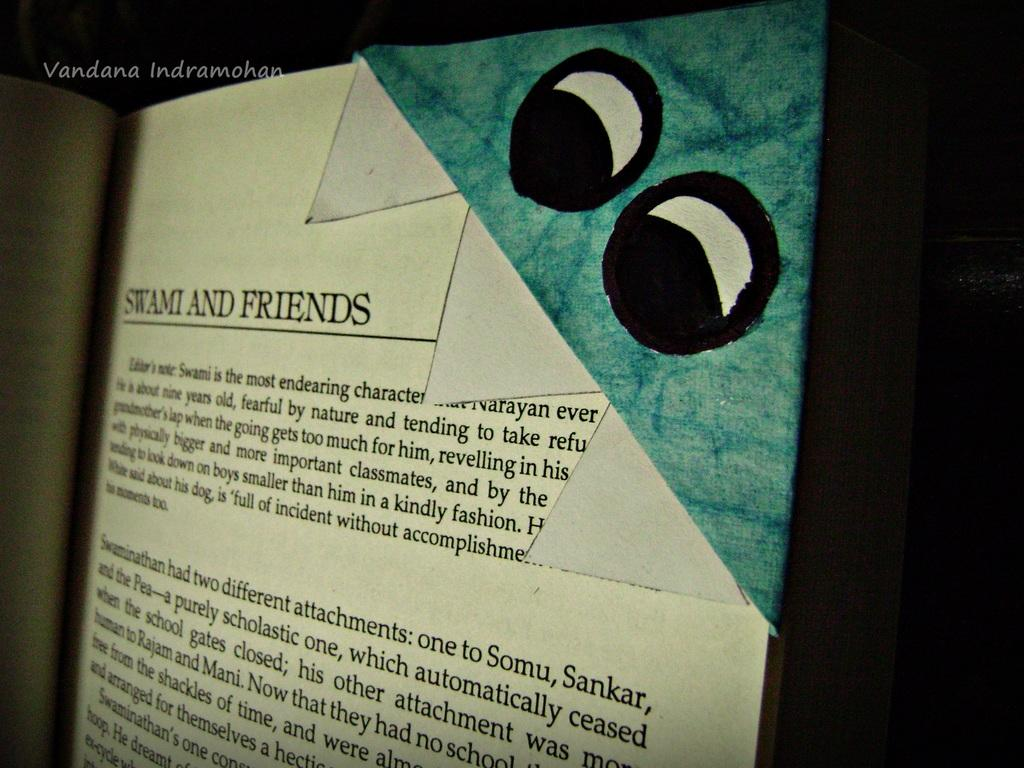What object can be seen in the image? There is a book in the image. How would you describe the background of the image? The background of the image is dark. Can you identify any additional features in the image? There is a watermark in the left top of the image. How many cows are present in the image? There are no cows present in the image; it features a book and a watermark. What type of ball can be seen in the image? There is no ball present in the image. 